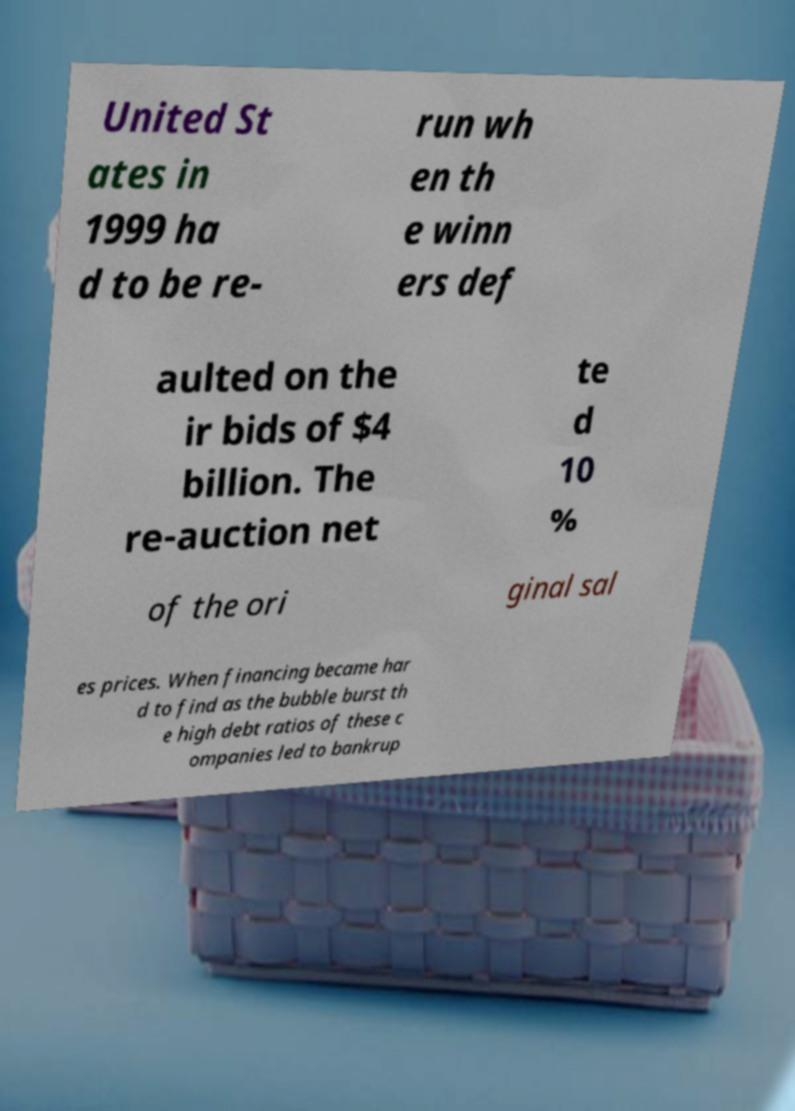What messages or text are displayed in this image? I need them in a readable, typed format. United St ates in 1999 ha d to be re- run wh en th e winn ers def aulted on the ir bids of $4 billion. The re-auction net te d 10 % of the ori ginal sal es prices. When financing became har d to find as the bubble burst th e high debt ratios of these c ompanies led to bankrup 